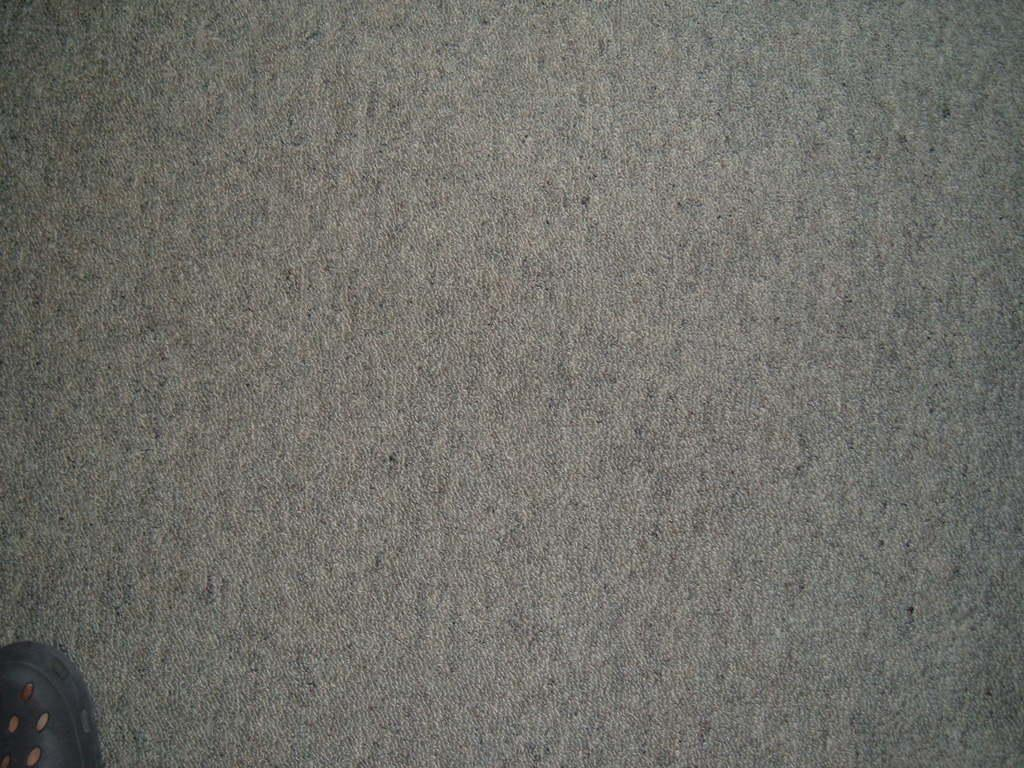What part of a person's body can be seen in the bottom left corner of the image? There is a person's leg with a shoe visible in the bottom left corner of the image. What type of surface is visible in the background of the image? There is a road in the background of the image. How many friends are pushing the pan in the image? There are no friends or pans present in the image. 